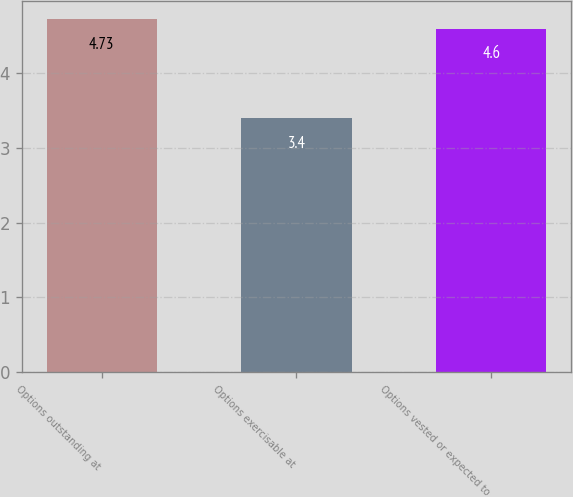<chart> <loc_0><loc_0><loc_500><loc_500><bar_chart><fcel>Options outstanding at<fcel>Options exercisable at<fcel>Options vested or expected to<nl><fcel>4.73<fcel>3.4<fcel>4.6<nl></chart> 